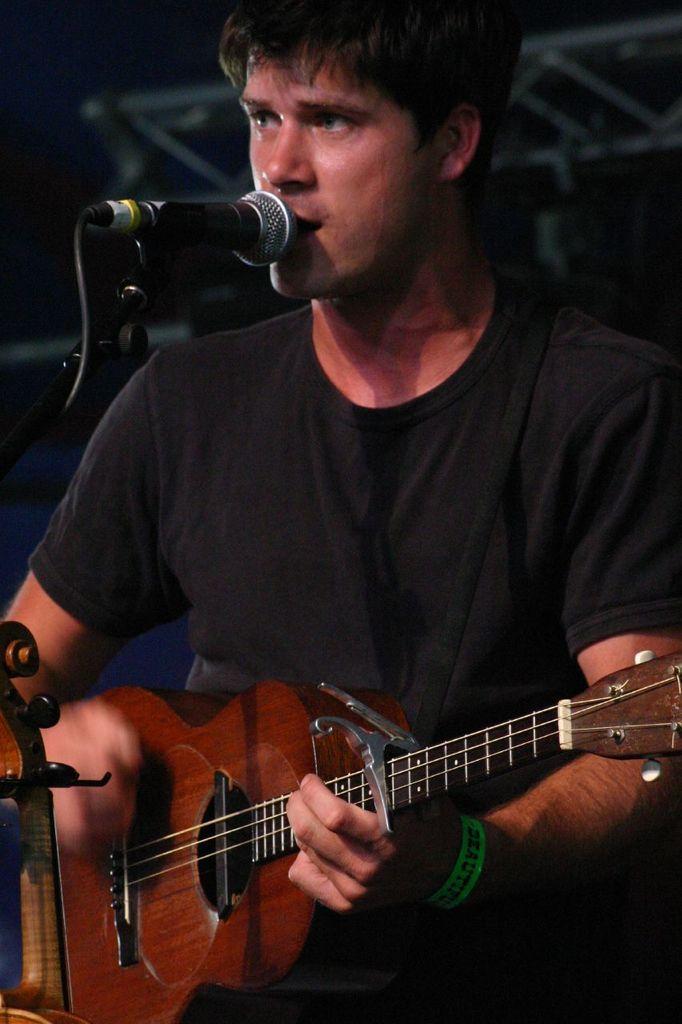Describe this image in one or two sentences. This man is playing a guitar and singing in-front of a mic. 